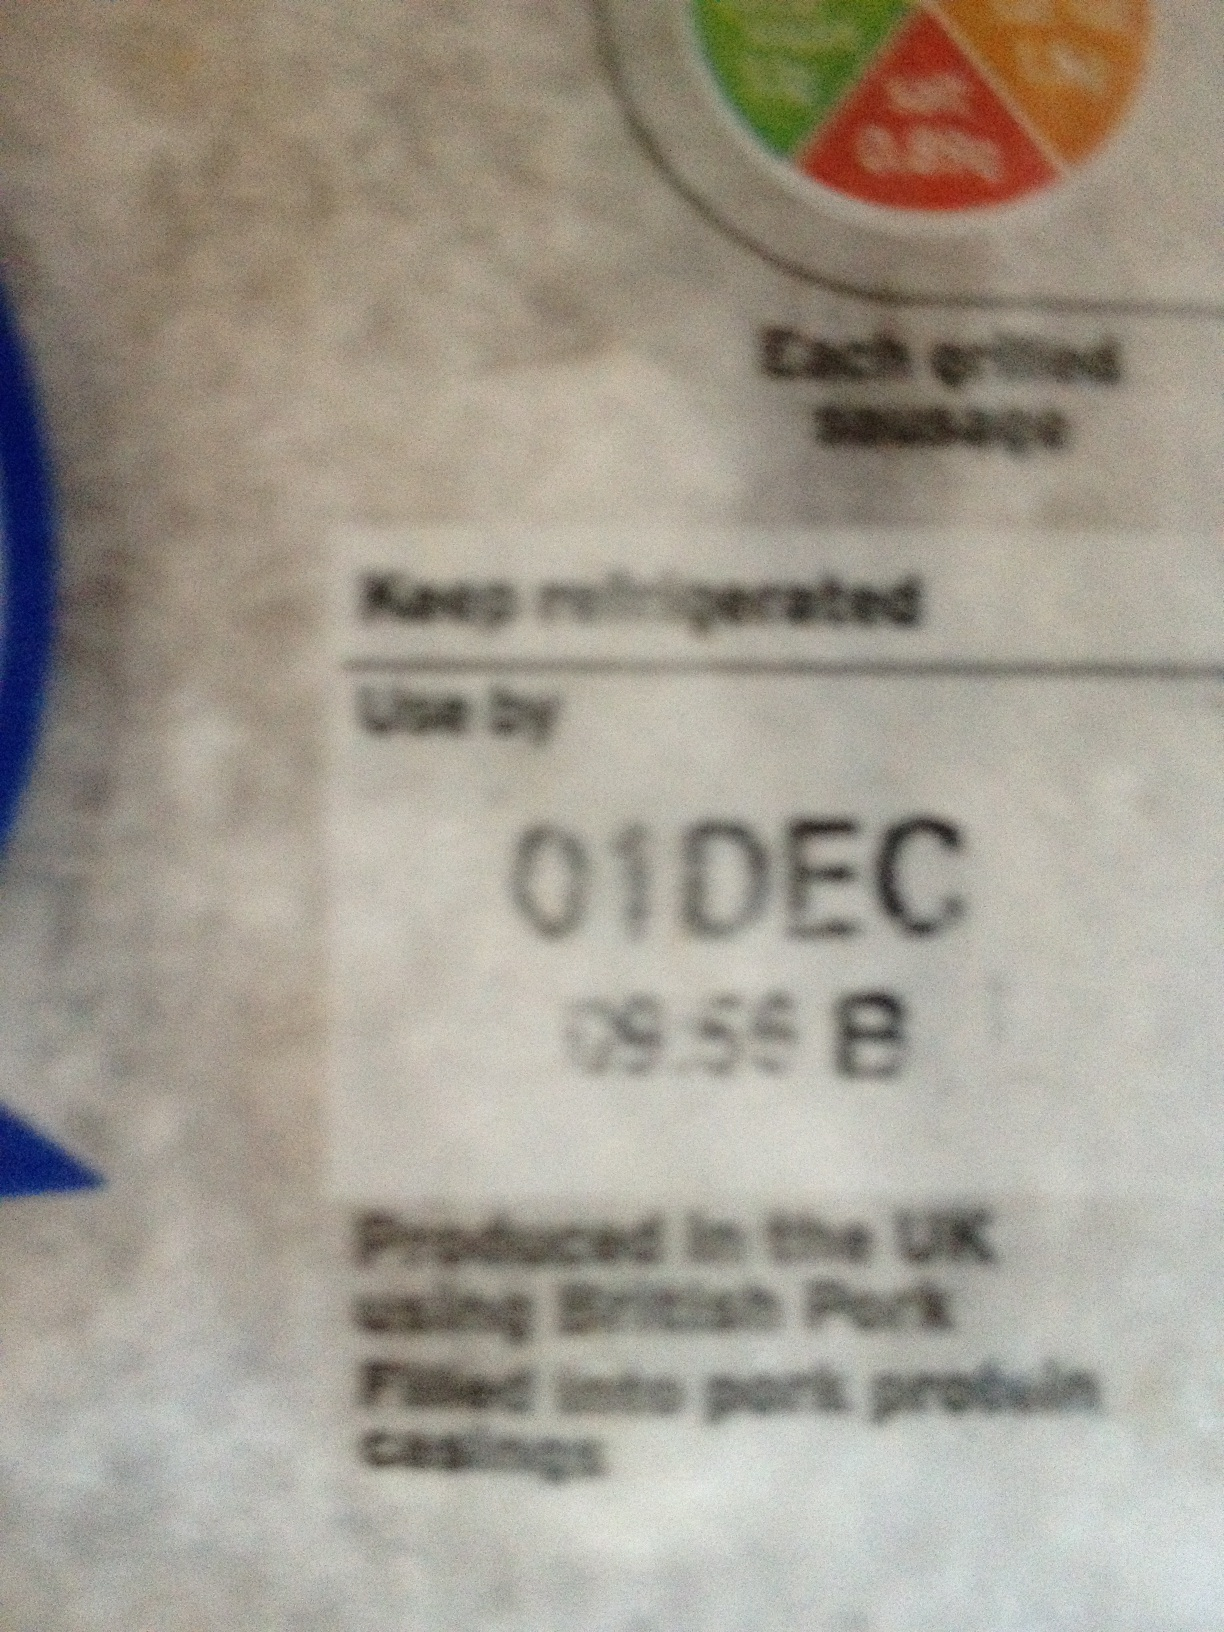Oh so do I leave it in for twelve months then do I? No, you should not leave it for twelve months. The 'Use by' date on the label clearly indicates that the product should be consumed by December 1st, otherwise, it may not be safe to eat. 